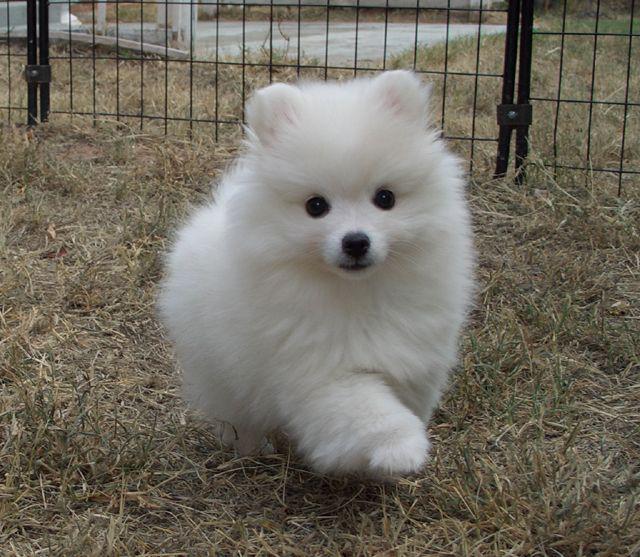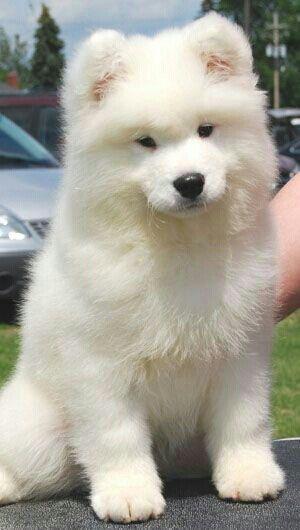The first image is the image on the left, the second image is the image on the right. For the images shown, is this caption "There are two samoyed dogs outside in the center of the images." true? Answer yes or no. Yes. The first image is the image on the left, the second image is the image on the right. Evaluate the accuracy of this statement regarding the images: "There is a white dog facing the right with trees in the background.". Is it true? Answer yes or no. No. 